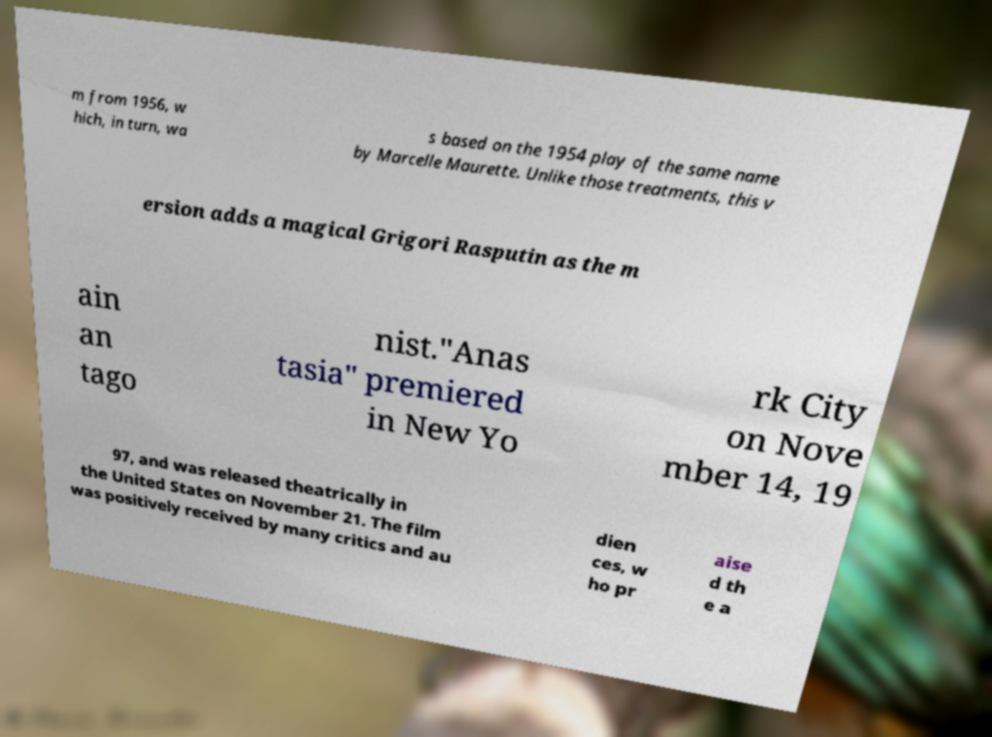Please identify and transcribe the text found in this image. m from 1956, w hich, in turn, wa s based on the 1954 play of the same name by Marcelle Maurette. Unlike those treatments, this v ersion adds a magical Grigori Rasputin as the m ain an tago nist."Anas tasia" premiered in New Yo rk City on Nove mber 14, 19 97, and was released theatrically in the United States on November 21. The film was positively received by many critics and au dien ces, w ho pr aise d th e a 